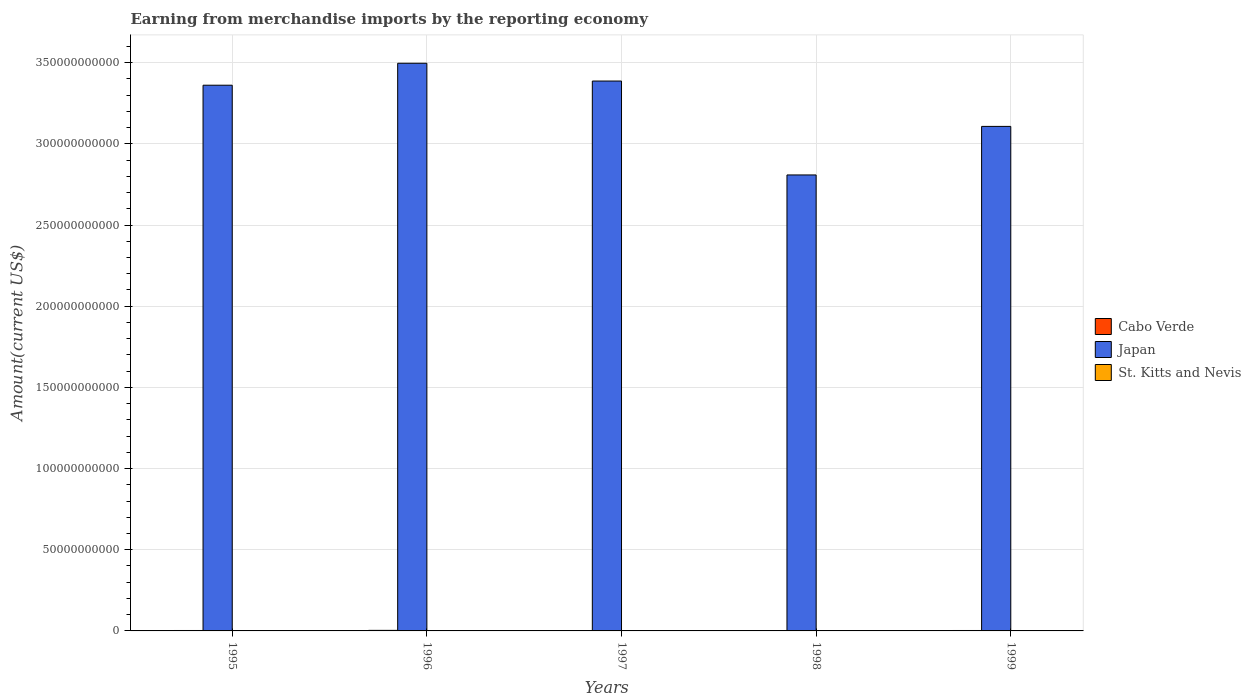Are the number of bars per tick equal to the number of legend labels?
Your answer should be very brief. Yes. What is the label of the 1st group of bars from the left?
Provide a short and direct response. 1995. What is the amount earned from merchandise imports in Cabo Verde in 1996?
Your answer should be very brief. 3.40e+08. Across all years, what is the maximum amount earned from merchandise imports in St. Kitts and Nevis?
Give a very brief answer. 1.77e+08. Across all years, what is the minimum amount earned from merchandise imports in Cabo Verde?
Your answer should be compact. 2.30e+08. In which year was the amount earned from merchandise imports in St. Kitts and Nevis minimum?
Keep it short and to the point. 1996. What is the total amount earned from merchandise imports in St. Kitts and Nevis in the graph?
Offer a terse response. 8.07e+08. What is the difference between the amount earned from merchandise imports in St. Kitts and Nevis in 1995 and that in 1997?
Ensure brevity in your answer.  8.44e+06. What is the difference between the amount earned from merchandise imports in Cabo Verde in 1996 and the amount earned from merchandise imports in Japan in 1995?
Give a very brief answer. -3.36e+11. What is the average amount earned from merchandise imports in St. Kitts and Nevis per year?
Make the answer very short. 1.61e+08. In the year 1996, what is the difference between the amount earned from merchandise imports in St. Kitts and Nevis and amount earned from merchandise imports in Cabo Verde?
Ensure brevity in your answer.  -2.08e+08. In how many years, is the amount earned from merchandise imports in St. Kitts and Nevis greater than 60000000000 US$?
Offer a terse response. 0. What is the ratio of the amount earned from merchandise imports in Cabo Verde in 1997 to that in 1999?
Offer a terse response. 0.89. Is the difference between the amount earned from merchandise imports in St. Kitts and Nevis in 1996 and 1997 greater than the difference between the amount earned from merchandise imports in Cabo Verde in 1996 and 1997?
Provide a short and direct response. No. What is the difference between the highest and the second highest amount earned from merchandise imports in St. Kitts and Nevis?
Keep it short and to the point. 7.56e+05. What is the difference between the highest and the lowest amount earned from merchandise imports in St. Kitts and Nevis?
Offer a very short reply. 4.42e+07. In how many years, is the amount earned from merchandise imports in St. Kitts and Nevis greater than the average amount earned from merchandise imports in St. Kitts and Nevis taken over all years?
Offer a terse response. 3. Is the sum of the amount earned from merchandise imports in St. Kitts and Nevis in 1996 and 1999 greater than the maximum amount earned from merchandise imports in Japan across all years?
Offer a terse response. No. What does the 2nd bar from the left in 1998 represents?
Offer a terse response. Japan. What does the 3rd bar from the right in 1998 represents?
Give a very brief answer. Cabo Verde. Does the graph contain any zero values?
Your answer should be compact. No. Does the graph contain grids?
Provide a succinct answer. Yes. Where does the legend appear in the graph?
Give a very brief answer. Center right. What is the title of the graph?
Your answer should be very brief. Earning from merchandise imports by the reporting economy. What is the label or title of the Y-axis?
Keep it short and to the point. Amount(current US$). What is the Amount(current US$) in Cabo Verde in 1995?
Offer a very short reply. 2.60e+08. What is the Amount(current US$) of Japan in 1995?
Provide a short and direct response. 3.36e+11. What is the Amount(current US$) of St. Kitts and Nevis in 1995?
Your response must be concise. 1.76e+08. What is the Amount(current US$) in Cabo Verde in 1996?
Make the answer very short. 3.40e+08. What is the Amount(current US$) of Japan in 1996?
Keep it short and to the point. 3.50e+11. What is the Amount(current US$) in St. Kitts and Nevis in 1996?
Offer a very short reply. 1.33e+08. What is the Amount(current US$) of Cabo Verde in 1997?
Offer a terse response. 2.34e+08. What is the Amount(current US$) in Japan in 1997?
Provide a succinct answer. 3.39e+11. What is the Amount(current US$) of St. Kitts and Nevis in 1997?
Your response must be concise. 1.68e+08. What is the Amount(current US$) of Cabo Verde in 1998?
Ensure brevity in your answer.  2.30e+08. What is the Amount(current US$) in Japan in 1998?
Provide a succinct answer. 2.81e+11. What is the Amount(current US$) of St. Kitts and Nevis in 1998?
Provide a short and direct response. 1.77e+08. What is the Amount(current US$) in Cabo Verde in 1999?
Offer a terse response. 2.62e+08. What is the Amount(current US$) in Japan in 1999?
Provide a short and direct response. 3.11e+11. What is the Amount(current US$) in St. Kitts and Nevis in 1999?
Your answer should be very brief. 1.54e+08. Across all years, what is the maximum Amount(current US$) in Cabo Verde?
Offer a very short reply. 3.40e+08. Across all years, what is the maximum Amount(current US$) in Japan?
Make the answer very short. 3.50e+11. Across all years, what is the maximum Amount(current US$) of St. Kitts and Nevis?
Provide a succinct answer. 1.77e+08. Across all years, what is the minimum Amount(current US$) in Cabo Verde?
Your response must be concise. 2.30e+08. Across all years, what is the minimum Amount(current US$) of Japan?
Your response must be concise. 2.81e+11. Across all years, what is the minimum Amount(current US$) in St. Kitts and Nevis?
Give a very brief answer. 1.33e+08. What is the total Amount(current US$) in Cabo Verde in the graph?
Ensure brevity in your answer.  1.33e+09. What is the total Amount(current US$) in Japan in the graph?
Offer a terse response. 1.62e+12. What is the total Amount(current US$) in St. Kitts and Nevis in the graph?
Provide a succinct answer. 8.07e+08. What is the difference between the Amount(current US$) of Cabo Verde in 1995 and that in 1996?
Your answer should be very brief. -7.97e+07. What is the difference between the Amount(current US$) in Japan in 1995 and that in 1996?
Your answer should be very brief. -1.35e+1. What is the difference between the Amount(current US$) in St. Kitts and Nevis in 1995 and that in 1996?
Your answer should be compact. 4.35e+07. What is the difference between the Amount(current US$) of Cabo Verde in 1995 and that in 1997?
Make the answer very short. 2.69e+07. What is the difference between the Amount(current US$) in Japan in 1995 and that in 1997?
Offer a terse response. -2.57e+09. What is the difference between the Amount(current US$) of St. Kitts and Nevis in 1995 and that in 1997?
Provide a succinct answer. 8.44e+06. What is the difference between the Amount(current US$) in Cabo Verde in 1995 and that in 1998?
Make the answer very short. 3.03e+07. What is the difference between the Amount(current US$) in Japan in 1995 and that in 1998?
Ensure brevity in your answer.  5.53e+1. What is the difference between the Amount(current US$) in St. Kitts and Nevis in 1995 and that in 1998?
Offer a very short reply. -7.56e+05. What is the difference between the Amount(current US$) of Cabo Verde in 1995 and that in 1999?
Give a very brief answer. -1.59e+06. What is the difference between the Amount(current US$) in Japan in 1995 and that in 1999?
Make the answer very short. 2.54e+1. What is the difference between the Amount(current US$) of St. Kitts and Nevis in 1995 and that in 1999?
Offer a very short reply. 2.26e+07. What is the difference between the Amount(current US$) in Cabo Verde in 1996 and that in 1997?
Make the answer very short. 1.07e+08. What is the difference between the Amount(current US$) of Japan in 1996 and that in 1997?
Your answer should be very brief. 1.10e+1. What is the difference between the Amount(current US$) of St. Kitts and Nevis in 1996 and that in 1997?
Give a very brief answer. -3.50e+07. What is the difference between the Amount(current US$) in Cabo Verde in 1996 and that in 1998?
Provide a short and direct response. 1.10e+08. What is the difference between the Amount(current US$) of Japan in 1996 and that in 1998?
Ensure brevity in your answer.  6.88e+1. What is the difference between the Amount(current US$) of St. Kitts and Nevis in 1996 and that in 1998?
Offer a terse response. -4.42e+07. What is the difference between the Amount(current US$) in Cabo Verde in 1996 and that in 1999?
Ensure brevity in your answer.  7.81e+07. What is the difference between the Amount(current US$) in Japan in 1996 and that in 1999?
Offer a very short reply. 3.89e+1. What is the difference between the Amount(current US$) in St. Kitts and Nevis in 1996 and that in 1999?
Provide a short and direct response. -2.09e+07. What is the difference between the Amount(current US$) in Cabo Verde in 1997 and that in 1998?
Your answer should be very brief. 3.36e+06. What is the difference between the Amount(current US$) of Japan in 1997 and that in 1998?
Make the answer very short. 5.78e+1. What is the difference between the Amount(current US$) in St. Kitts and Nevis in 1997 and that in 1998?
Ensure brevity in your answer.  -9.20e+06. What is the difference between the Amount(current US$) in Cabo Verde in 1997 and that in 1999?
Your answer should be very brief. -2.85e+07. What is the difference between the Amount(current US$) in Japan in 1997 and that in 1999?
Your answer should be very brief. 2.79e+1. What is the difference between the Amount(current US$) in St. Kitts and Nevis in 1997 and that in 1999?
Offer a terse response. 1.41e+07. What is the difference between the Amount(current US$) of Cabo Verde in 1998 and that in 1999?
Your response must be concise. -3.19e+07. What is the difference between the Amount(current US$) of Japan in 1998 and that in 1999?
Offer a terse response. -2.99e+1. What is the difference between the Amount(current US$) of St. Kitts and Nevis in 1998 and that in 1999?
Make the answer very short. 2.33e+07. What is the difference between the Amount(current US$) of Cabo Verde in 1995 and the Amount(current US$) of Japan in 1996?
Make the answer very short. -3.49e+11. What is the difference between the Amount(current US$) in Cabo Verde in 1995 and the Amount(current US$) in St. Kitts and Nevis in 1996?
Your answer should be very brief. 1.28e+08. What is the difference between the Amount(current US$) of Japan in 1995 and the Amount(current US$) of St. Kitts and Nevis in 1996?
Make the answer very short. 3.36e+11. What is the difference between the Amount(current US$) in Cabo Verde in 1995 and the Amount(current US$) in Japan in 1997?
Your response must be concise. -3.38e+11. What is the difference between the Amount(current US$) of Cabo Verde in 1995 and the Amount(current US$) of St. Kitts and Nevis in 1997?
Give a very brief answer. 9.28e+07. What is the difference between the Amount(current US$) of Japan in 1995 and the Amount(current US$) of St. Kitts and Nevis in 1997?
Your answer should be compact. 3.36e+11. What is the difference between the Amount(current US$) of Cabo Verde in 1995 and the Amount(current US$) of Japan in 1998?
Keep it short and to the point. -2.81e+11. What is the difference between the Amount(current US$) of Cabo Verde in 1995 and the Amount(current US$) of St. Kitts and Nevis in 1998?
Keep it short and to the point. 8.36e+07. What is the difference between the Amount(current US$) of Japan in 1995 and the Amount(current US$) of St. Kitts and Nevis in 1998?
Give a very brief answer. 3.36e+11. What is the difference between the Amount(current US$) in Cabo Verde in 1995 and the Amount(current US$) in Japan in 1999?
Make the answer very short. -3.11e+11. What is the difference between the Amount(current US$) in Cabo Verde in 1995 and the Amount(current US$) in St. Kitts and Nevis in 1999?
Offer a very short reply. 1.07e+08. What is the difference between the Amount(current US$) of Japan in 1995 and the Amount(current US$) of St. Kitts and Nevis in 1999?
Provide a short and direct response. 3.36e+11. What is the difference between the Amount(current US$) in Cabo Verde in 1996 and the Amount(current US$) in Japan in 1997?
Keep it short and to the point. -3.38e+11. What is the difference between the Amount(current US$) of Cabo Verde in 1996 and the Amount(current US$) of St. Kitts and Nevis in 1997?
Ensure brevity in your answer.  1.72e+08. What is the difference between the Amount(current US$) in Japan in 1996 and the Amount(current US$) in St. Kitts and Nevis in 1997?
Keep it short and to the point. 3.49e+11. What is the difference between the Amount(current US$) of Cabo Verde in 1996 and the Amount(current US$) of Japan in 1998?
Your response must be concise. -2.81e+11. What is the difference between the Amount(current US$) of Cabo Verde in 1996 and the Amount(current US$) of St. Kitts and Nevis in 1998?
Make the answer very short. 1.63e+08. What is the difference between the Amount(current US$) in Japan in 1996 and the Amount(current US$) in St. Kitts and Nevis in 1998?
Your response must be concise. 3.49e+11. What is the difference between the Amount(current US$) of Cabo Verde in 1996 and the Amount(current US$) of Japan in 1999?
Offer a very short reply. -3.10e+11. What is the difference between the Amount(current US$) of Cabo Verde in 1996 and the Amount(current US$) of St. Kitts and Nevis in 1999?
Your answer should be compact. 1.87e+08. What is the difference between the Amount(current US$) of Japan in 1996 and the Amount(current US$) of St. Kitts and Nevis in 1999?
Make the answer very short. 3.50e+11. What is the difference between the Amount(current US$) in Cabo Verde in 1997 and the Amount(current US$) in Japan in 1998?
Your answer should be compact. -2.81e+11. What is the difference between the Amount(current US$) in Cabo Verde in 1997 and the Amount(current US$) in St. Kitts and Nevis in 1998?
Keep it short and to the point. 5.67e+07. What is the difference between the Amount(current US$) in Japan in 1997 and the Amount(current US$) in St. Kitts and Nevis in 1998?
Keep it short and to the point. 3.39e+11. What is the difference between the Amount(current US$) in Cabo Verde in 1997 and the Amount(current US$) in Japan in 1999?
Your answer should be compact. -3.11e+11. What is the difference between the Amount(current US$) in Cabo Verde in 1997 and the Amount(current US$) in St. Kitts and Nevis in 1999?
Your response must be concise. 8.00e+07. What is the difference between the Amount(current US$) of Japan in 1997 and the Amount(current US$) of St. Kitts and Nevis in 1999?
Provide a short and direct response. 3.39e+11. What is the difference between the Amount(current US$) of Cabo Verde in 1998 and the Amount(current US$) of Japan in 1999?
Provide a succinct answer. -3.11e+11. What is the difference between the Amount(current US$) of Cabo Verde in 1998 and the Amount(current US$) of St. Kitts and Nevis in 1999?
Make the answer very short. 7.67e+07. What is the difference between the Amount(current US$) of Japan in 1998 and the Amount(current US$) of St. Kitts and Nevis in 1999?
Give a very brief answer. 2.81e+11. What is the average Amount(current US$) in Cabo Verde per year?
Your answer should be very brief. 2.65e+08. What is the average Amount(current US$) of Japan per year?
Offer a terse response. 3.23e+11. What is the average Amount(current US$) in St. Kitts and Nevis per year?
Ensure brevity in your answer.  1.61e+08. In the year 1995, what is the difference between the Amount(current US$) of Cabo Verde and Amount(current US$) of Japan?
Keep it short and to the point. -3.36e+11. In the year 1995, what is the difference between the Amount(current US$) of Cabo Verde and Amount(current US$) of St. Kitts and Nevis?
Offer a very short reply. 8.44e+07. In the year 1995, what is the difference between the Amount(current US$) of Japan and Amount(current US$) of St. Kitts and Nevis?
Ensure brevity in your answer.  3.36e+11. In the year 1996, what is the difference between the Amount(current US$) of Cabo Verde and Amount(current US$) of Japan?
Your answer should be compact. -3.49e+11. In the year 1996, what is the difference between the Amount(current US$) in Cabo Verde and Amount(current US$) in St. Kitts and Nevis?
Your response must be concise. 2.08e+08. In the year 1996, what is the difference between the Amount(current US$) of Japan and Amount(current US$) of St. Kitts and Nevis?
Your answer should be very brief. 3.50e+11. In the year 1997, what is the difference between the Amount(current US$) in Cabo Verde and Amount(current US$) in Japan?
Provide a succinct answer. -3.38e+11. In the year 1997, what is the difference between the Amount(current US$) in Cabo Verde and Amount(current US$) in St. Kitts and Nevis?
Offer a terse response. 6.59e+07. In the year 1997, what is the difference between the Amount(current US$) of Japan and Amount(current US$) of St. Kitts and Nevis?
Offer a terse response. 3.39e+11. In the year 1998, what is the difference between the Amount(current US$) in Cabo Verde and Amount(current US$) in Japan?
Provide a succinct answer. -2.81e+11. In the year 1998, what is the difference between the Amount(current US$) of Cabo Verde and Amount(current US$) of St. Kitts and Nevis?
Provide a short and direct response. 5.33e+07. In the year 1998, what is the difference between the Amount(current US$) in Japan and Amount(current US$) in St. Kitts and Nevis?
Provide a short and direct response. 2.81e+11. In the year 1999, what is the difference between the Amount(current US$) of Cabo Verde and Amount(current US$) of Japan?
Offer a very short reply. -3.11e+11. In the year 1999, what is the difference between the Amount(current US$) in Cabo Verde and Amount(current US$) in St. Kitts and Nevis?
Give a very brief answer. 1.09e+08. In the year 1999, what is the difference between the Amount(current US$) of Japan and Amount(current US$) of St. Kitts and Nevis?
Ensure brevity in your answer.  3.11e+11. What is the ratio of the Amount(current US$) in Cabo Verde in 1995 to that in 1996?
Ensure brevity in your answer.  0.77. What is the ratio of the Amount(current US$) of Japan in 1995 to that in 1996?
Provide a short and direct response. 0.96. What is the ratio of the Amount(current US$) of St. Kitts and Nevis in 1995 to that in 1996?
Give a very brief answer. 1.33. What is the ratio of the Amount(current US$) in Cabo Verde in 1995 to that in 1997?
Offer a terse response. 1.12. What is the ratio of the Amount(current US$) of Japan in 1995 to that in 1997?
Ensure brevity in your answer.  0.99. What is the ratio of the Amount(current US$) of St. Kitts and Nevis in 1995 to that in 1997?
Give a very brief answer. 1.05. What is the ratio of the Amount(current US$) in Cabo Verde in 1995 to that in 1998?
Offer a very short reply. 1.13. What is the ratio of the Amount(current US$) of Japan in 1995 to that in 1998?
Offer a very short reply. 1.2. What is the ratio of the Amount(current US$) in Cabo Verde in 1995 to that in 1999?
Give a very brief answer. 0.99. What is the ratio of the Amount(current US$) in Japan in 1995 to that in 1999?
Your answer should be compact. 1.08. What is the ratio of the Amount(current US$) in St. Kitts and Nevis in 1995 to that in 1999?
Ensure brevity in your answer.  1.15. What is the ratio of the Amount(current US$) in Cabo Verde in 1996 to that in 1997?
Give a very brief answer. 1.46. What is the ratio of the Amount(current US$) of Japan in 1996 to that in 1997?
Keep it short and to the point. 1.03. What is the ratio of the Amount(current US$) of St. Kitts and Nevis in 1996 to that in 1997?
Offer a very short reply. 0.79. What is the ratio of the Amount(current US$) in Cabo Verde in 1996 to that in 1998?
Offer a very short reply. 1.48. What is the ratio of the Amount(current US$) in Japan in 1996 to that in 1998?
Give a very brief answer. 1.24. What is the ratio of the Amount(current US$) in St. Kitts and Nevis in 1996 to that in 1998?
Your response must be concise. 0.75. What is the ratio of the Amount(current US$) in Cabo Verde in 1996 to that in 1999?
Your answer should be very brief. 1.3. What is the ratio of the Amount(current US$) in Japan in 1996 to that in 1999?
Offer a terse response. 1.13. What is the ratio of the Amount(current US$) in St. Kitts and Nevis in 1996 to that in 1999?
Ensure brevity in your answer.  0.86. What is the ratio of the Amount(current US$) in Cabo Verde in 1997 to that in 1998?
Your response must be concise. 1.01. What is the ratio of the Amount(current US$) in Japan in 1997 to that in 1998?
Your response must be concise. 1.21. What is the ratio of the Amount(current US$) of St. Kitts and Nevis in 1997 to that in 1998?
Offer a very short reply. 0.95. What is the ratio of the Amount(current US$) of Cabo Verde in 1997 to that in 1999?
Your response must be concise. 0.89. What is the ratio of the Amount(current US$) of Japan in 1997 to that in 1999?
Keep it short and to the point. 1.09. What is the ratio of the Amount(current US$) in St. Kitts and Nevis in 1997 to that in 1999?
Your response must be concise. 1.09. What is the ratio of the Amount(current US$) of Cabo Verde in 1998 to that in 1999?
Your answer should be very brief. 0.88. What is the ratio of the Amount(current US$) in Japan in 1998 to that in 1999?
Offer a very short reply. 0.9. What is the ratio of the Amount(current US$) in St. Kitts and Nevis in 1998 to that in 1999?
Offer a very short reply. 1.15. What is the difference between the highest and the second highest Amount(current US$) of Cabo Verde?
Ensure brevity in your answer.  7.81e+07. What is the difference between the highest and the second highest Amount(current US$) in Japan?
Ensure brevity in your answer.  1.10e+1. What is the difference between the highest and the second highest Amount(current US$) in St. Kitts and Nevis?
Your response must be concise. 7.56e+05. What is the difference between the highest and the lowest Amount(current US$) of Cabo Verde?
Offer a terse response. 1.10e+08. What is the difference between the highest and the lowest Amount(current US$) of Japan?
Offer a very short reply. 6.88e+1. What is the difference between the highest and the lowest Amount(current US$) of St. Kitts and Nevis?
Provide a short and direct response. 4.42e+07. 